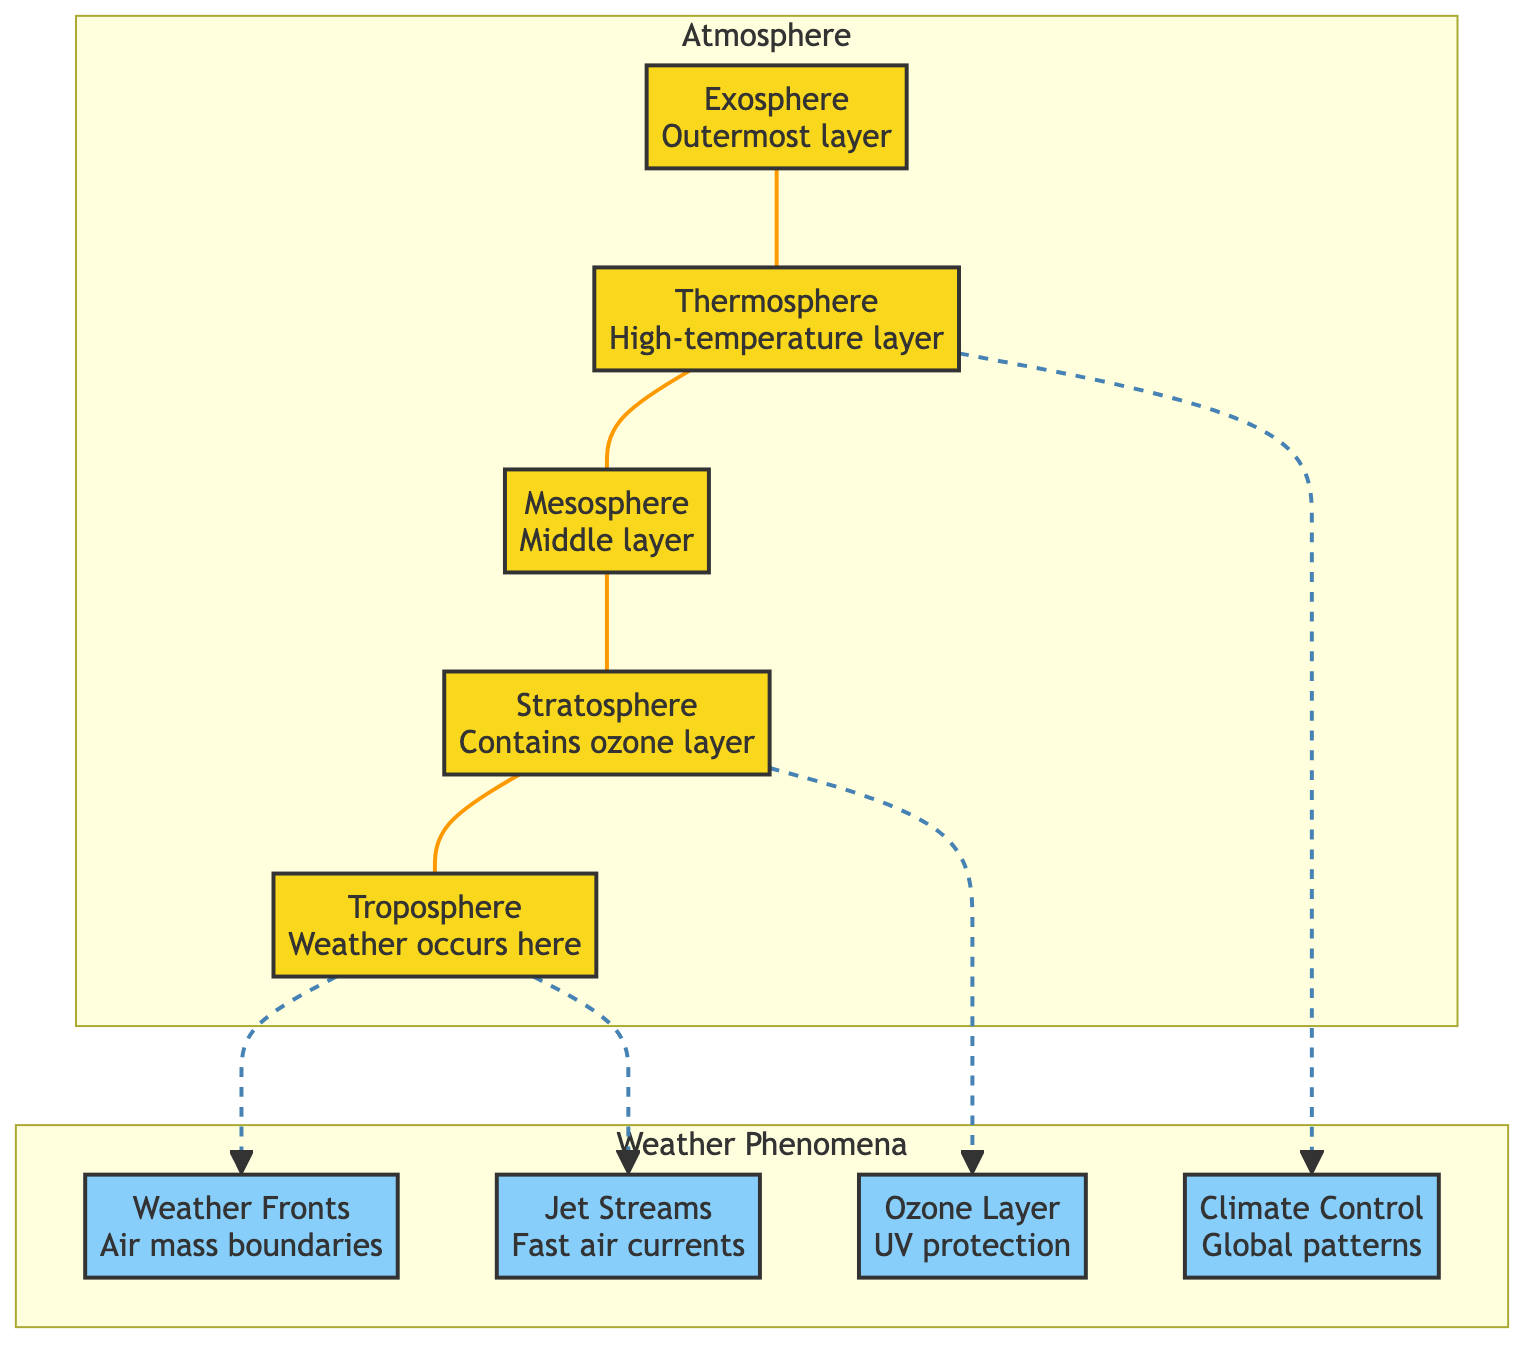What is the lowest layer of the atmosphere? The diagram shows the layers of the atmosphere stacked vertically. The first layer listed is the troposphere, which is explicitly labeled as the lowest layer.
Answer: Troposphere How many layers are in the atmosphere? The diagram contains five distinct layers of the atmosphere, namely the exosphere, thermosphere, mesosphere, stratosphere, and troposphere. This can be counted directly from the diagram.
Answer: Five What weather phenomena are associated with the troposphere? The troposphere is linked to two weather phenomena: weather fronts and jet streams. This can be determined by looking at the connections from the troposphere to these two elements in the diagram.
Answer: Weather Fronts, Jet Streams What layer contains the ozone layer? The ozone layer is specifically indicated as a part of the stratosphere in the diagram. This relationship can be seen where the stratosphere connects to the ozone layer in the system of boxes.
Answer: Stratosphere Which layer is directly above the troposphere? The diagram shows a clear hierarchical structure of layers, with the stratosphere visually positioned directly above the troposphere.
Answer: Stratosphere What is the relationship between the thermosphere and climate control? The thermosphere has a direct connection to climate control, as indicated by the arrow linking them in the diagram. This shows that climate control is affected by conditions in the thermosphere.
Answer: Direct relationship What phenomenon is associated with air mass boundaries? The diagram connects weather fronts to the troposphere, indicating that weather fronts represent air mass boundaries within that specific layer of the atmosphere.
Answer: Weather Fronts How are the ozone layer and the stratosphere linked? The diagram indicates a direct connection between the ozone layer and the stratosphere, highlighting that the ozone layer is contained within this atmospheric layer.
Answer: Direct connection What type of air currents are represented in the diagram? Jet streams, which are fast air currents, are explicitly mentioned in the diagram and are also linked to the troposphere in the flowchart.
Answer: Jet Streams 